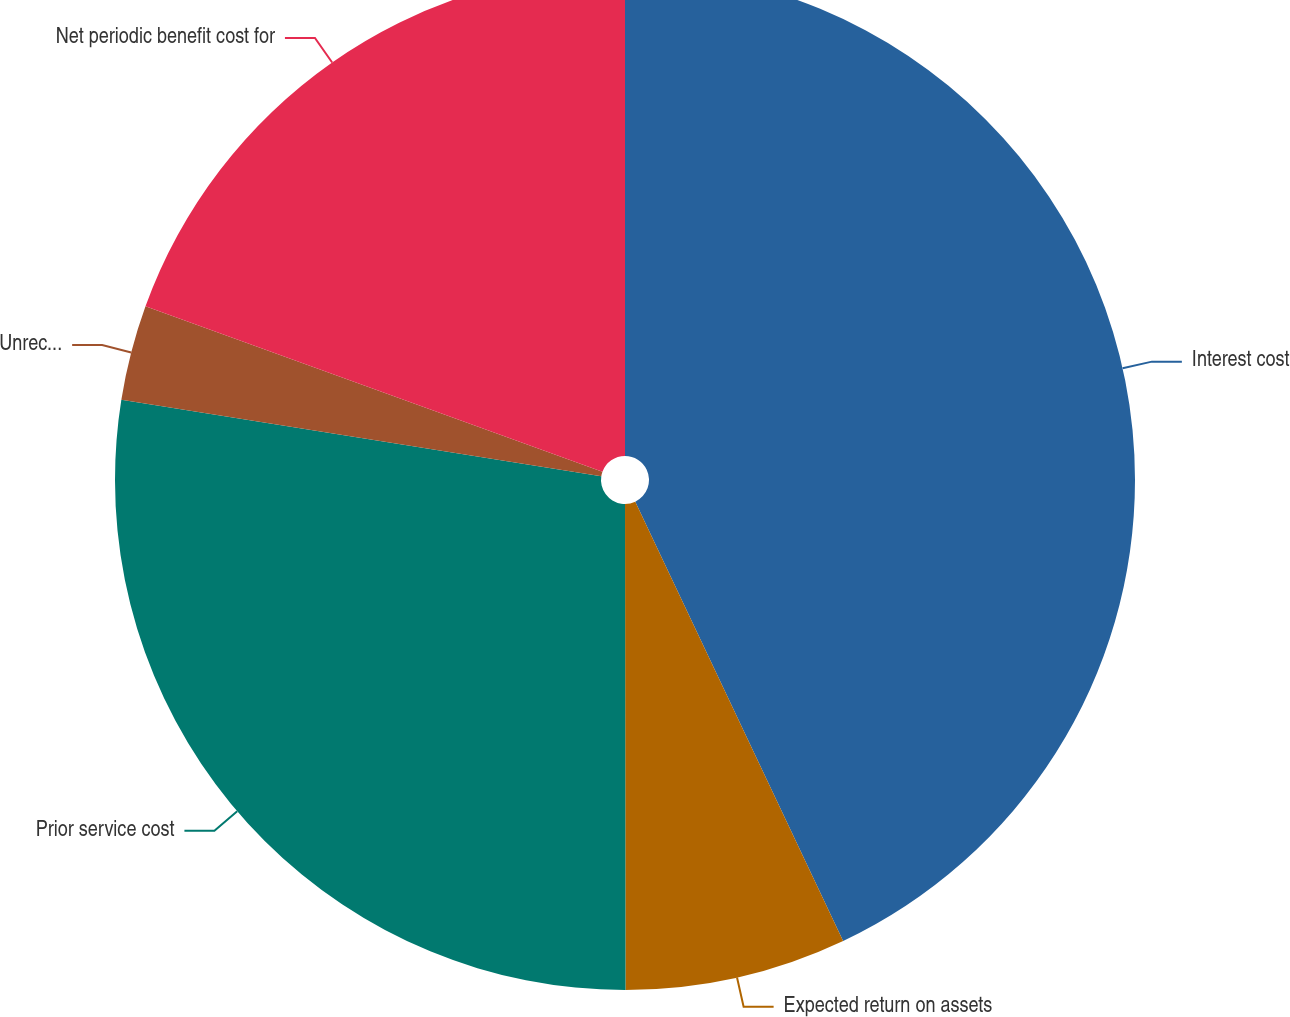<chart> <loc_0><loc_0><loc_500><loc_500><pie_chart><fcel>Interest cost<fcel>Expected return on assets<fcel>Prior service cost<fcel>Unrecognized net loss (gain)<fcel>Net periodic benefit cost for<nl><fcel>42.97%<fcel>7.02%<fcel>27.53%<fcel>3.02%<fcel>19.47%<nl></chart> 